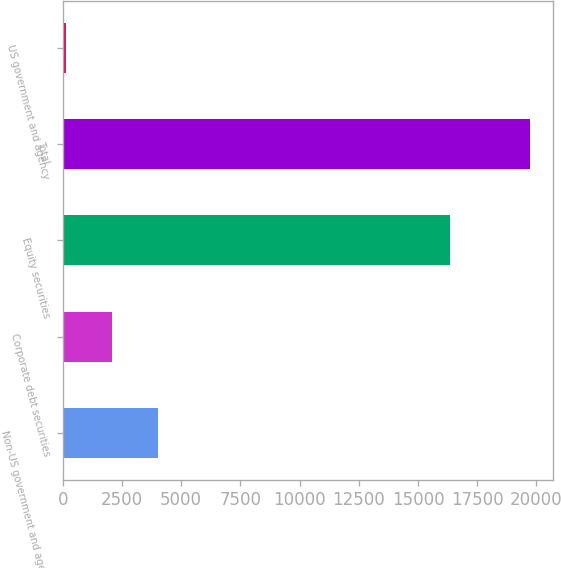Convert chart to OTSL. <chart><loc_0><loc_0><loc_500><loc_500><bar_chart><fcel>Non-US government and agency<fcel>Corporate debt securities<fcel>Equity securities<fcel>Total<fcel>US government and agency<nl><fcel>4037.6<fcel>2076.3<fcel>16338<fcel>19728<fcel>115<nl></chart> 